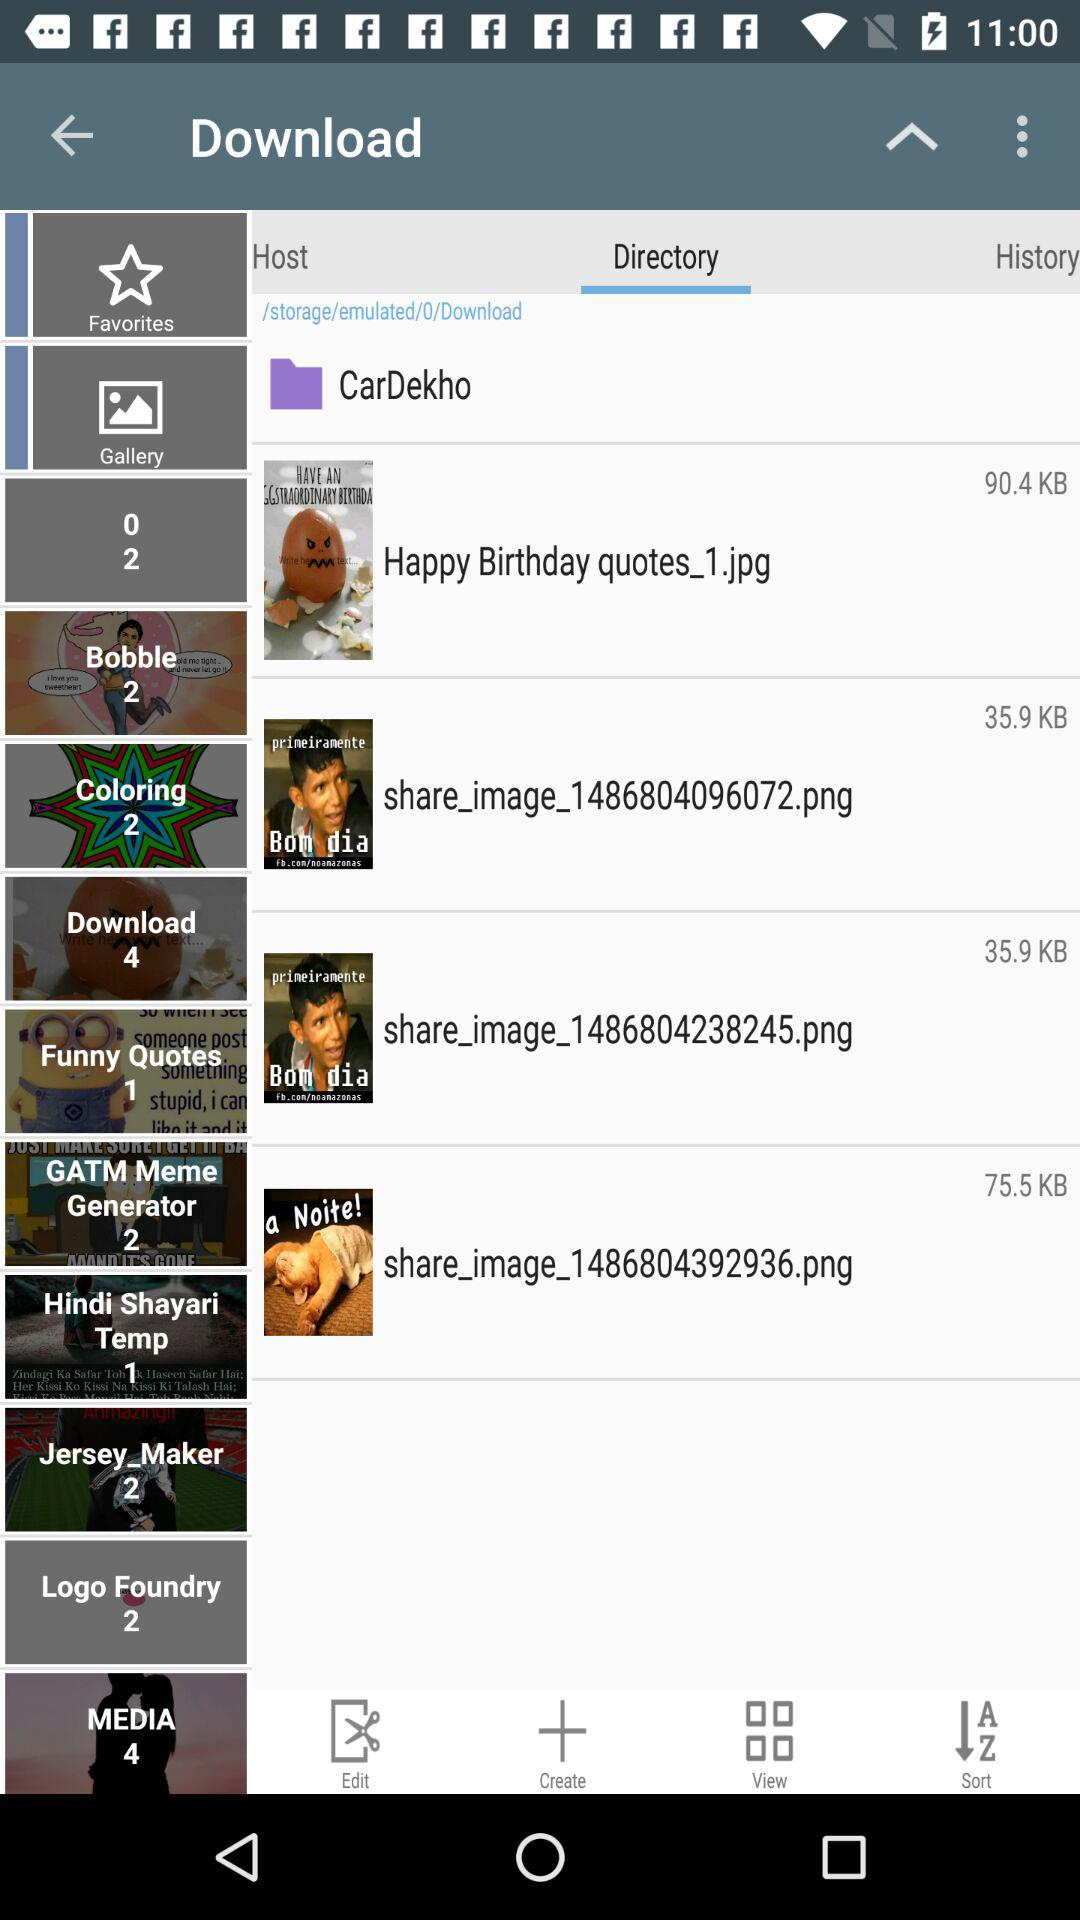How many KB is the largest file?
Answer the question using a single word or phrase. 90.4 KB 